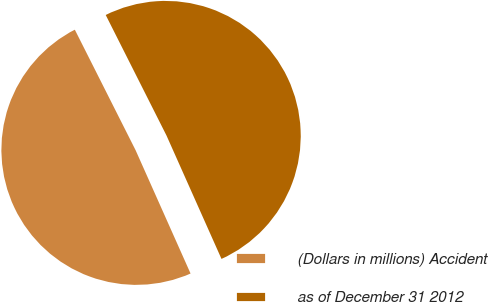<chart> <loc_0><loc_0><loc_500><loc_500><pie_chart><fcel>(Dollars in millions) Accident<fcel>as of December 31 2012<nl><fcel>49.24%<fcel>50.76%<nl></chart> 